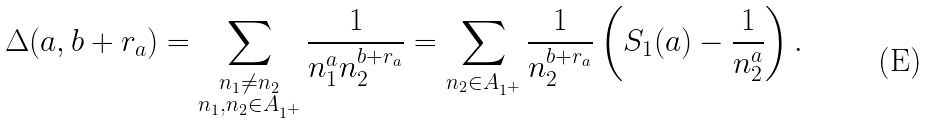<formula> <loc_0><loc_0><loc_500><loc_500>\Delta ( a , b + r _ { a } ) = \sum _ { \substack { { n _ { 1 } \ne n _ { 2 } } \\ { n _ { 1 } , n _ { 2 } \in A _ { 1 ^ { + } } } } } \frac { 1 } { n _ { 1 } ^ { a } n _ { 2 } ^ { b + r _ { a } } } = \sum _ { n _ { 2 } \in A _ { 1 ^ { + } } } \frac { 1 } { n _ { 2 } ^ { b + r _ { a } } } \left ( S _ { 1 } ( a ) - \frac { 1 } { n _ { 2 } ^ { a } } \right ) .</formula> 